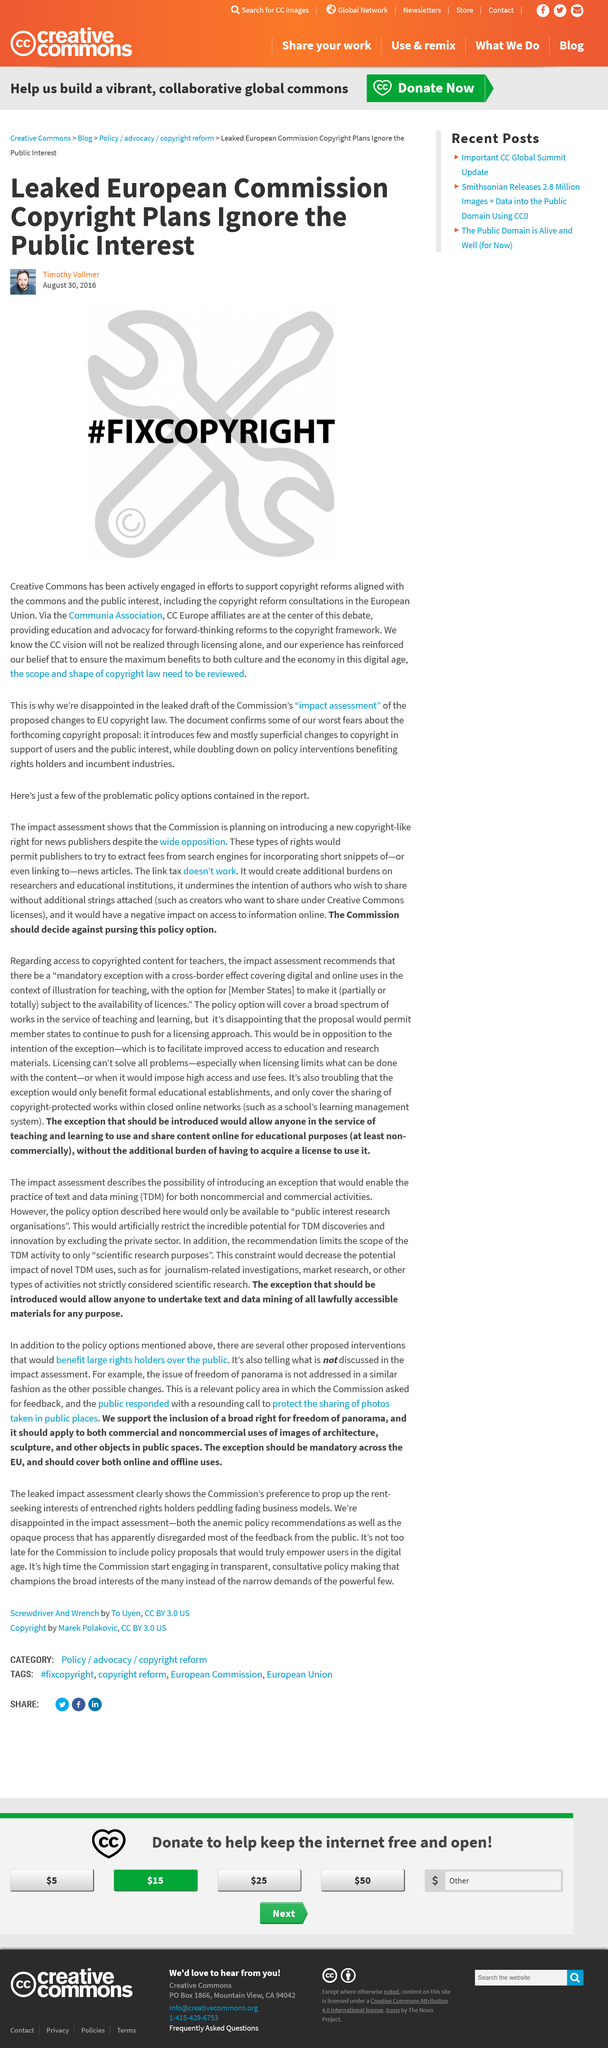List a handful of essential elements in this visual. On August 30th, 2016, Timothy Vollmer wrote this article. The man in the first image is Timothy Vollmer. The European Commission's leaked plans disregard the public interest. 